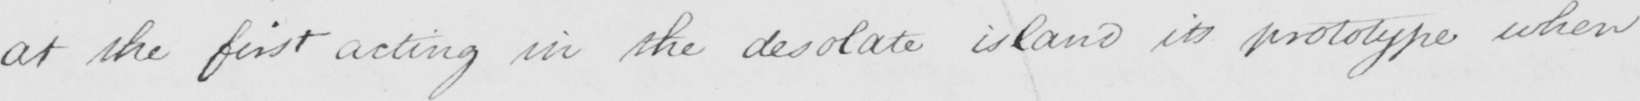Can you read and transcribe this handwriting? at the first acting in the desolate island its prototype when 